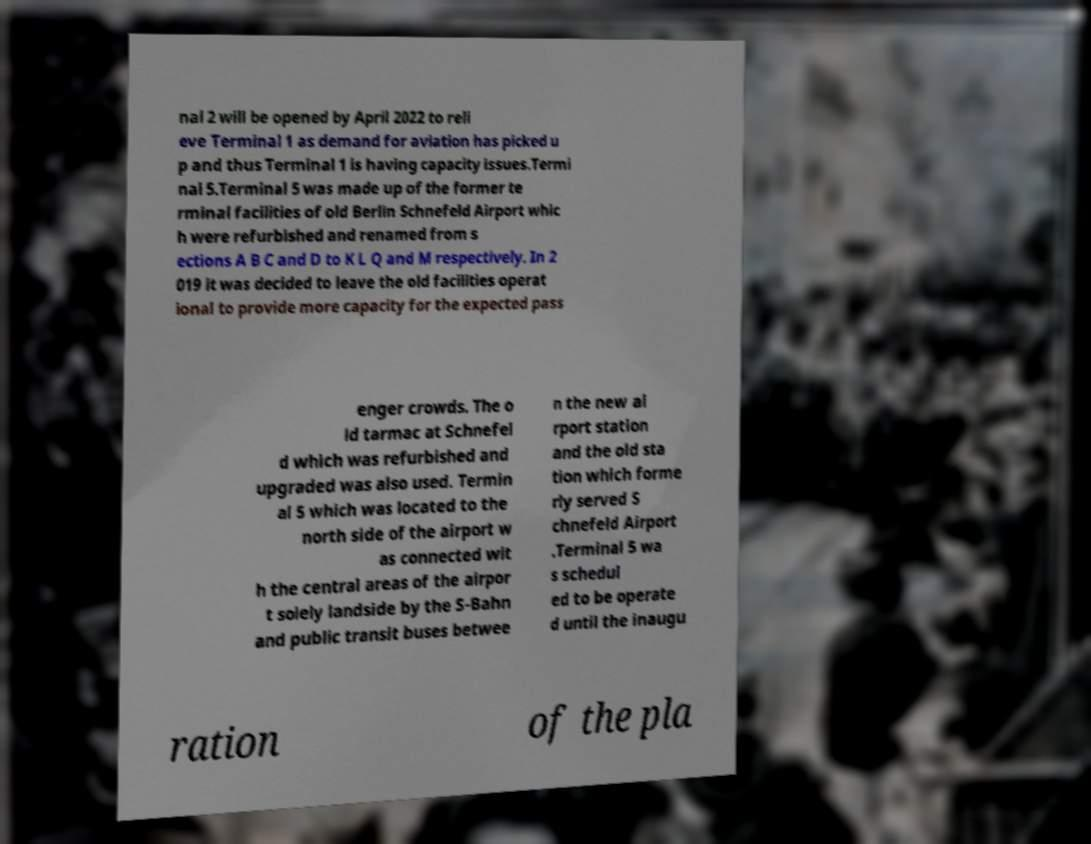There's text embedded in this image that I need extracted. Can you transcribe it verbatim? nal 2 will be opened by April 2022 to reli eve Terminal 1 as demand for aviation has picked u p and thus Terminal 1 is having capacity issues.Termi nal 5.Terminal 5 was made up of the former te rminal facilities of old Berlin Schnefeld Airport whic h were refurbished and renamed from s ections A B C and D to K L Q and M respectively. In 2 019 it was decided to leave the old facilities operat ional to provide more capacity for the expected pass enger crowds. The o ld tarmac at Schnefel d which was refurbished and upgraded was also used. Termin al 5 which was located to the north side of the airport w as connected wit h the central areas of the airpor t solely landside by the S-Bahn and public transit buses betwee n the new ai rport station and the old sta tion which forme rly served S chnefeld Airport .Terminal 5 wa s schedul ed to be operate d until the inaugu ration of the pla 